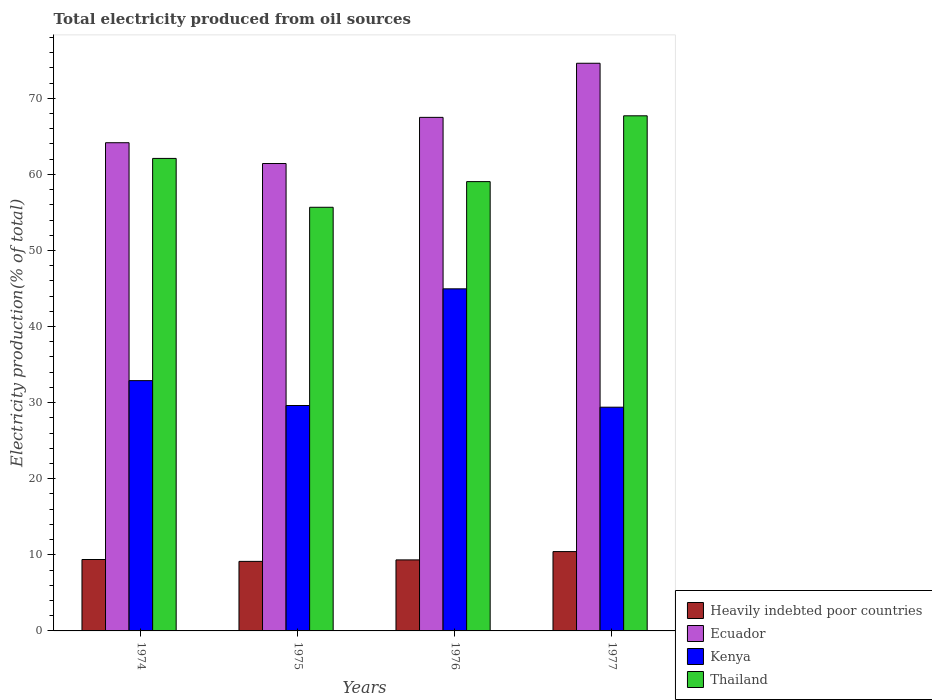How many groups of bars are there?
Ensure brevity in your answer.  4. Are the number of bars per tick equal to the number of legend labels?
Keep it short and to the point. Yes. How many bars are there on the 3rd tick from the left?
Give a very brief answer. 4. How many bars are there on the 2nd tick from the right?
Keep it short and to the point. 4. What is the label of the 1st group of bars from the left?
Your answer should be compact. 1974. What is the total electricity produced in Ecuador in 1974?
Offer a terse response. 64.16. Across all years, what is the maximum total electricity produced in Heavily indebted poor countries?
Make the answer very short. 10.43. Across all years, what is the minimum total electricity produced in Thailand?
Give a very brief answer. 55.68. In which year was the total electricity produced in Thailand maximum?
Your answer should be very brief. 1977. In which year was the total electricity produced in Thailand minimum?
Offer a very short reply. 1975. What is the total total electricity produced in Kenya in the graph?
Your answer should be compact. 136.87. What is the difference between the total electricity produced in Heavily indebted poor countries in 1974 and that in 1975?
Provide a succinct answer. 0.24. What is the difference between the total electricity produced in Thailand in 1977 and the total electricity produced in Heavily indebted poor countries in 1974?
Offer a very short reply. 58.31. What is the average total electricity produced in Kenya per year?
Give a very brief answer. 34.22. In the year 1975, what is the difference between the total electricity produced in Thailand and total electricity produced in Heavily indebted poor countries?
Your answer should be very brief. 46.54. What is the ratio of the total electricity produced in Ecuador in 1974 to that in 1977?
Your response must be concise. 0.86. Is the difference between the total electricity produced in Thailand in 1974 and 1977 greater than the difference between the total electricity produced in Heavily indebted poor countries in 1974 and 1977?
Offer a very short reply. No. What is the difference between the highest and the second highest total electricity produced in Heavily indebted poor countries?
Keep it short and to the point. 1.04. What is the difference between the highest and the lowest total electricity produced in Heavily indebted poor countries?
Offer a terse response. 1.29. Is the sum of the total electricity produced in Thailand in 1974 and 1977 greater than the maximum total electricity produced in Ecuador across all years?
Offer a terse response. Yes. Is it the case that in every year, the sum of the total electricity produced in Thailand and total electricity produced in Kenya is greater than the sum of total electricity produced in Heavily indebted poor countries and total electricity produced in Ecuador?
Provide a short and direct response. Yes. What does the 4th bar from the left in 1975 represents?
Ensure brevity in your answer.  Thailand. What does the 3rd bar from the right in 1974 represents?
Your answer should be very brief. Ecuador. Is it the case that in every year, the sum of the total electricity produced in Kenya and total electricity produced in Heavily indebted poor countries is greater than the total electricity produced in Ecuador?
Your answer should be compact. No. How many bars are there?
Offer a terse response. 16. What is the difference between two consecutive major ticks on the Y-axis?
Provide a succinct answer. 10. Are the values on the major ticks of Y-axis written in scientific E-notation?
Ensure brevity in your answer.  No. Does the graph contain any zero values?
Your answer should be very brief. No. How many legend labels are there?
Ensure brevity in your answer.  4. What is the title of the graph?
Your answer should be very brief. Total electricity produced from oil sources. Does "Bahrain" appear as one of the legend labels in the graph?
Ensure brevity in your answer.  No. What is the label or title of the X-axis?
Offer a very short reply. Years. What is the label or title of the Y-axis?
Provide a succinct answer. Electricity production(% of total). What is the Electricity production(% of total) in Heavily indebted poor countries in 1974?
Offer a terse response. 9.38. What is the Electricity production(% of total) of Ecuador in 1974?
Provide a succinct answer. 64.16. What is the Electricity production(% of total) in Kenya in 1974?
Provide a succinct answer. 32.89. What is the Electricity production(% of total) in Thailand in 1974?
Make the answer very short. 62.1. What is the Electricity production(% of total) of Heavily indebted poor countries in 1975?
Offer a very short reply. 9.14. What is the Electricity production(% of total) in Ecuador in 1975?
Ensure brevity in your answer.  61.43. What is the Electricity production(% of total) of Kenya in 1975?
Offer a terse response. 29.62. What is the Electricity production(% of total) in Thailand in 1975?
Give a very brief answer. 55.68. What is the Electricity production(% of total) in Heavily indebted poor countries in 1976?
Keep it short and to the point. 9.33. What is the Electricity production(% of total) in Ecuador in 1976?
Your response must be concise. 67.49. What is the Electricity production(% of total) in Kenya in 1976?
Offer a terse response. 44.96. What is the Electricity production(% of total) in Thailand in 1976?
Make the answer very short. 59.05. What is the Electricity production(% of total) in Heavily indebted poor countries in 1977?
Your response must be concise. 10.43. What is the Electricity production(% of total) of Ecuador in 1977?
Provide a short and direct response. 74.6. What is the Electricity production(% of total) of Kenya in 1977?
Offer a very short reply. 29.4. What is the Electricity production(% of total) of Thailand in 1977?
Give a very brief answer. 67.7. Across all years, what is the maximum Electricity production(% of total) of Heavily indebted poor countries?
Ensure brevity in your answer.  10.43. Across all years, what is the maximum Electricity production(% of total) of Ecuador?
Keep it short and to the point. 74.6. Across all years, what is the maximum Electricity production(% of total) of Kenya?
Ensure brevity in your answer.  44.96. Across all years, what is the maximum Electricity production(% of total) in Thailand?
Provide a short and direct response. 67.7. Across all years, what is the minimum Electricity production(% of total) of Heavily indebted poor countries?
Keep it short and to the point. 9.14. Across all years, what is the minimum Electricity production(% of total) in Ecuador?
Your answer should be compact. 61.43. Across all years, what is the minimum Electricity production(% of total) in Kenya?
Keep it short and to the point. 29.4. Across all years, what is the minimum Electricity production(% of total) in Thailand?
Offer a very short reply. 55.68. What is the total Electricity production(% of total) in Heavily indebted poor countries in the graph?
Offer a terse response. 38.28. What is the total Electricity production(% of total) of Ecuador in the graph?
Provide a short and direct response. 267.68. What is the total Electricity production(% of total) of Kenya in the graph?
Your answer should be compact. 136.87. What is the total Electricity production(% of total) of Thailand in the graph?
Your answer should be very brief. 244.51. What is the difference between the Electricity production(% of total) in Heavily indebted poor countries in 1974 and that in 1975?
Your answer should be compact. 0.24. What is the difference between the Electricity production(% of total) in Ecuador in 1974 and that in 1975?
Your response must be concise. 2.73. What is the difference between the Electricity production(% of total) of Kenya in 1974 and that in 1975?
Offer a terse response. 3.27. What is the difference between the Electricity production(% of total) of Thailand in 1974 and that in 1975?
Make the answer very short. 6.42. What is the difference between the Electricity production(% of total) in Heavily indebted poor countries in 1974 and that in 1976?
Provide a succinct answer. 0.05. What is the difference between the Electricity production(% of total) in Ecuador in 1974 and that in 1976?
Provide a succinct answer. -3.33. What is the difference between the Electricity production(% of total) of Kenya in 1974 and that in 1976?
Your answer should be very brief. -12.06. What is the difference between the Electricity production(% of total) of Thailand in 1974 and that in 1976?
Give a very brief answer. 3.05. What is the difference between the Electricity production(% of total) in Heavily indebted poor countries in 1974 and that in 1977?
Keep it short and to the point. -1.04. What is the difference between the Electricity production(% of total) in Ecuador in 1974 and that in 1977?
Your answer should be very brief. -10.44. What is the difference between the Electricity production(% of total) in Kenya in 1974 and that in 1977?
Give a very brief answer. 3.49. What is the difference between the Electricity production(% of total) of Thailand in 1974 and that in 1977?
Ensure brevity in your answer.  -5.6. What is the difference between the Electricity production(% of total) in Heavily indebted poor countries in 1975 and that in 1976?
Your answer should be very brief. -0.2. What is the difference between the Electricity production(% of total) of Ecuador in 1975 and that in 1976?
Ensure brevity in your answer.  -6.07. What is the difference between the Electricity production(% of total) of Kenya in 1975 and that in 1976?
Give a very brief answer. -15.33. What is the difference between the Electricity production(% of total) of Thailand in 1975 and that in 1976?
Offer a terse response. -3.37. What is the difference between the Electricity production(% of total) of Heavily indebted poor countries in 1975 and that in 1977?
Provide a succinct answer. -1.29. What is the difference between the Electricity production(% of total) of Ecuador in 1975 and that in 1977?
Your response must be concise. -13.18. What is the difference between the Electricity production(% of total) of Kenya in 1975 and that in 1977?
Provide a succinct answer. 0.22. What is the difference between the Electricity production(% of total) of Thailand in 1975 and that in 1977?
Ensure brevity in your answer.  -12.02. What is the difference between the Electricity production(% of total) of Heavily indebted poor countries in 1976 and that in 1977?
Your response must be concise. -1.09. What is the difference between the Electricity production(% of total) in Ecuador in 1976 and that in 1977?
Your answer should be compact. -7.11. What is the difference between the Electricity production(% of total) in Kenya in 1976 and that in 1977?
Your answer should be compact. 15.55. What is the difference between the Electricity production(% of total) of Thailand in 1976 and that in 1977?
Offer a terse response. -8.65. What is the difference between the Electricity production(% of total) of Heavily indebted poor countries in 1974 and the Electricity production(% of total) of Ecuador in 1975?
Make the answer very short. -52.04. What is the difference between the Electricity production(% of total) of Heavily indebted poor countries in 1974 and the Electricity production(% of total) of Kenya in 1975?
Offer a terse response. -20.24. What is the difference between the Electricity production(% of total) in Heavily indebted poor countries in 1974 and the Electricity production(% of total) in Thailand in 1975?
Offer a very short reply. -46.29. What is the difference between the Electricity production(% of total) in Ecuador in 1974 and the Electricity production(% of total) in Kenya in 1975?
Offer a very short reply. 34.53. What is the difference between the Electricity production(% of total) in Ecuador in 1974 and the Electricity production(% of total) in Thailand in 1975?
Provide a short and direct response. 8.48. What is the difference between the Electricity production(% of total) of Kenya in 1974 and the Electricity production(% of total) of Thailand in 1975?
Your answer should be compact. -22.78. What is the difference between the Electricity production(% of total) of Heavily indebted poor countries in 1974 and the Electricity production(% of total) of Ecuador in 1976?
Give a very brief answer. -58.11. What is the difference between the Electricity production(% of total) of Heavily indebted poor countries in 1974 and the Electricity production(% of total) of Kenya in 1976?
Provide a short and direct response. -35.57. What is the difference between the Electricity production(% of total) of Heavily indebted poor countries in 1974 and the Electricity production(% of total) of Thailand in 1976?
Provide a succinct answer. -49.66. What is the difference between the Electricity production(% of total) in Ecuador in 1974 and the Electricity production(% of total) in Kenya in 1976?
Keep it short and to the point. 19.2. What is the difference between the Electricity production(% of total) in Ecuador in 1974 and the Electricity production(% of total) in Thailand in 1976?
Offer a terse response. 5.11. What is the difference between the Electricity production(% of total) of Kenya in 1974 and the Electricity production(% of total) of Thailand in 1976?
Ensure brevity in your answer.  -26.16. What is the difference between the Electricity production(% of total) in Heavily indebted poor countries in 1974 and the Electricity production(% of total) in Ecuador in 1977?
Ensure brevity in your answer.  -65.22. What is the difference between the Electricity production(% of total) in Heavily indebted poor countries in 1974 and the Electricity production(% of total) in Kenya in 1977?
Give a very brief answer. -20.02. What is the difference between the Electricity production(% of total) of Heavily indebted poor countries in 1974 and the Electricity production(% of total) of Thailand in 1977?
Your answer should be very brief. -58.31. What is the difference between the Electricity production(% of total) of Ecuador in 1974 and the Electricity production(% of total) of Kenya in 1977?
Give a very brief answer. 34.76. What is the difference between the Electricity production(% of total) of Ecuador in 1974 and the Electricity production(% of total) of Thailand in 1977?
Provide a succinct answer. -3.54. What is the difference between the Electricity production(% of total) in Kenya in 1974 and the Electricity production(% of total) in Thailand in 1977?
Make the answer very short. -34.8. What is the difference between the Electricity production(% of total) of Heavily indebted poor countries in 1975 and the Electricity production(% of total) of Ecuador in 1976?
Make the answer very short. -58.35. What is the difference between the Electricity production(% of total) in Heavily indebted poor countries in 1975 and the Electricity production(% of total) in Kenya in 1976?
Your answer should be very brief. -35.82. What is the difference between the Electricity production(% of total) of Heavily indebted poor countries in 1975 and the Electricity production(% of total) of Thailand in 1976?
Offer a terse response. -49.91. What is the difference between the Electricity production(% of total) of Ecuador in 1975 and the Electricity production(% of total) of Kenya in 1976?
Make the answer very short. 16.47. What is the difference between the Electricity production(% of total) of Ecuador in 1975 and the Electricity production(% of total) of Thailand in 1976?
Give a very brief answer. 2.38. What is the difference between the Electricity production(% of total) of Kenya in 1975 and the Electricity production(% of total) of Thailand in 1976?
Give a very brief answer. -29.42. What is the difference between the Electricity production(% of total) of Heavily indebted poor countries in 1975 and the Electricity production(% of total) of Ecuador in 1977?
Give a very brief answer. -65.46. What is the difference between the Electricity production(% of total) in Heavily indebted poor countries in 1975 and the Electricity production(% of total) in Kenya in 1977?
Your answer should be very brief. -20.26. What is the difference between the Electricity production(% of total) in Heavily indebted poor countries in 1975 and the Electricity production(% of total) in Thailand in 1977?
Offer a very short reply. -58.56. What is the difference between the Electricity production(% of total) in Ecuador in 1975 and the Electricity production(% of total) in Kenya in 1977?
Give a very brief answer. 32.02. What is the difference between the Electricity production(% of total) in Ecuador in 1975 and the Electricity production(% of total) in Thailand in 1977?
Your response must be concise. -6.27. What is the difference between the Electricity production(% of total) in Kenya in 1975 and the Electricity production(% of total) in Thailand in 1977?
Offer a terse response. -38.07. What is the difference between the Electricity production(% of total) in Heavily indebted poor countries in 1976 and the Electricity production(% of total) in Ecuador in 1977?
Ensure brevity in your answer.  -65.27. What is the difference between the Electricity production(% of total) in Heavily indebted poor countries in 1976 and the Electricity production(% of total) in Kenya in 1977?
Give a very brief answer. -20.07. What is the difference between the Electricity production(% of total) of Heavily indebted poor countries in 1976 and the Electricity production(% of total) of Thailand in 1977?
Keep it short and to the point. -58.36. What is the difference between the Electricity production(% of total) in Ecuador in 1976 and the Electricity production(% of total) in Kenya in 1977?
Offer a very short reply. 38.09. What is the difference between the Electricity production(% of total) in Ecuador in 1976 and the Electricity production(% of total) in Thailand in 1977?
Provide a short and direct response. -0.21. What is the difference between the Electricity production(% of total) of Kenya in 1976 and the Electricity production(% of total) of Thailand in 1977?
Your response must be concise. -22.74. What is the average Electricity production(% of total) of Heavily indebted poor countries per year?
Offer a terse response. 9.57. What is the average Electricity production(% of total) of Ecuador per year?
Offer a terse response. 66.92. What is the average Electricity production(% of total) in Kenya per year?
Provide a short and direct response. 34.22. What is the average Electricity production(% of total) in Thailand per year?
Provide a succinct answer. 61.13. In the year 1974, what is the difference between the Electricity production(% of total) of Heavily indebted poor countries and Electricity production(% of total) of Ecuador?
Keep it short and to the point. -54.77. In the year 1974, what is the difference between the Electricity production(% of total) in Heavily indebted poor countries and Electricity production(% of total) in Kenya?
Make the answer very short. -23.51. In the year 1974, what is the difference between the Electricity production(% of total) in Heavily indebted poor countries and Electricity production(% of total) in Thailand?
Your response must be concise. -52.71. In the year 1974, what is the difference between the Electricity production(% of total) in Ecuador and Electricity production(% of total) in Kenya?
Give a very brief answer. 31.27. In the year 1974, what is the difference between the Electricity production(% of total) of Ecuador and Electricity production(% of total) of Thailand?
Provide a short and direct response. 2.06. In the year 1974, what is the difference between the Electricity production(% of total) of Kenya and Electricity production(% of total) of Thailand?
Give a very brief answer. -29.2. In the year 1975, what is the difference between the Electricity production(% of total) of Heavily indebted poor countries and Electricity production(% of total) of Ecuador?
Offer a terse response. -52.29. In the year 1975, what is the difference between the Electricity production(% of total) of Heavily indebted poor countries and Electricity production(% of total) of Kenya?
Make the answer very short. -20.48. In the year 1975, what is the difference between the Electricity production(% of total) of Heavily indebted poor countries and Electricity production(% of total) of Thailand?
Offer a terse response. -46.54. In the year 1975, what is the difference between the Electricity production(% of total) in Ecuador and Electricity production(% of total) in Kenya?
Keep it short and to the point. 31.8. In the year 1975, what is the difference between the Electricity production(% of total) of Ecuador and Electricity production(% of total) of Thailand?
Offer a terse response. 5.75. In the year 1975, what is the difference between the Electricity production(% of total) of Kenya and Electricity production(% of total) of Thailand?
Offer a very short reply. -26.05. In the year 1976, what is the difference between the Electricity production(% of total) of Heavily indebted poor countries and Electricity production(% of total) of Ecuador?
Ensure brevity in your answer.  -58.16. In the year 1976, what is the difference between the Electricity production(% of total) of Heavily indebted poor countries and Electricity production(% of total) of Kenya?
Make the answer very short. -35.62. In the year 1976, what is the difference between the Electricity production(% of total) in Heavily indebted poor countries and Electricity production(% of total) in Thailand?
Ensure brevity in your answer.  -49.71. In the year 1976, what is the difference between the Electricity production(% of total) of Ecuador and Electricity production(% of total) of Kenya?
Give a very brief answer. 22.53. In the year 1976, what is the difference between the Electricity production(% of total) in Ecuador and Electricity production(% of total) in Thailand?
Your response must be concise. 8.44. In the year 1976, what is the difference between the Electricity production(% of total) of Kenya and Electricity production(% of total) of Thailand?
Give a very brief answer. -14.09. In the year 1977, what is the difference between the Electricity production(% of total) in Heavily indebted poor countries and Electricity production(% of total) in Ecuador?
Your response must be concise. -64.18. In the year 1977, what is the difference between the Electricity production(% of total) of Heavily indebted poor countries and Electricity production(% of total) of Kenya?
Your answer should be compact. -18.98. In the year 1977, what is the difference between the Electricity production(% of total) of Heavily indebted poor countries and Electricity production(% of total) of Thailand?
Your response must be concise. -57.27. In the year 1977, what is the difference between the Electricity production(% of total) in Ecuador and Electricity production(% of total) in Kenya?
Your answer should be compact. 45.2. In the year 1977, what is the difference between the Electricity production(% of total) of Ecuador and Electricity production(% of total) of Thailand?
Give a very brief answer. 6.91. In the year 1977, what is the difference between the Electricity production(% of total) in Kenya and Electricity production(% of total) in Thailand?
Make the answer very short. -38.29. What is the ratio of the Electricity production(% of total) of Heavily indebted poor countries in 1974 to that in 1975?
Provide a short and direct response. 1.03. What is the ratio of the Electricity production(% of total) in Ecuador in 1974 to that in 1975?
Make the answer very short. 1.04. What is the ratio of the Electricity production(% of total) in Kenya in 1974 to that in 1975?
Ensure brevity in your answer.  1.11. What is the ratio of the Electricity production(% of total) of Thailand in 1974 to that in 1975?
Offer a very short reply. 1.12. What is the ratio of the Electricity production(% of total) in Heavily indebted poor countries in 1974 to that in 1976?
Make the answer very short. 1.01. What is the ratio of the Electricity production(% of total) in Ecuador in 1974 to that in 1976?
Provide a succinct answer. 0.95. What is the ratio of the Electricity production(% of total) in Kenya in 1974 to that in 1976?
Give a very brief answer. 0.73. What is the ratio of the Electricity production(% of total) in Thailand in 1974 to that in 1976?
Make the answer very short. 1.05. What is the ratio of the Electricity production(% of total) of Heavily indebted poor countries in 1974 to that in 1977?
Your answer should be very brief. 0.9. What is the ratio of the Electricity production(% of total) in Ecuador in 1974 to that in 1977?
Give a very brief answer. 0.86. What is the ratio of the Electricity production(% of total) in Kenya in 1974 to that in 1977?
Your response must be concise. 1.12. What is the ratio of the Electricity production(% of total) in Thailand in 1974 to that in 1977?
Ensure brevity in your answer.  0.92. What is the ratio of the Electricity production(% of total) of Heavily indebted poor countries in 1975 to that in 1976?
Your answer should be very brief. 0.98. What is the ratio of the Electricity production(% of total) in Ecuador in 1975 to that in 1976?
Your response must be concise. 0.91. What is the ratio of the Electricity production(% of total) in Kenya in 1975 to that in 1976?
Provide a succinct answer. 0.66. What is the ratio of the Electricity production(% of total) of Thailand in 1975 to that in 1976?
Your response must be concise. 0.94. What is the ratio of the Electricity production(% of total) in Heavily indebted poor countries in 1975 to that in 1977?
Give a very brief answer. 0.88. What is the ratio of the Electricity production(% of total) in Ecuador in 1975 to that in 1977?
Offer a very short reply. 0.82. What is the ratio of the Electricity production(% of total) of Kenya in 1975 to that in 1977?
Your answer should be compact. 1.01. What is the ratio of the Electricity production(% of total) of Thailand in 1975 to that in 1977?
Offer a very short reply. 0.82. What is the ratio of the Electricity production(% of total) in Heavily indebted poor countries in 1976 to that in 1977?
Offer a very short reply. 0.9. What is the ratio of the Electricity production(% of total) in Ecuador in 1976 to that in 1977?
Offer a very short reply. 0.9. What is the ratio of the Electricity production(% of total) in Kenya in 1976 to that in 1977?
Keep it short and to the point. 1.53. What is the ratio of the Electricity production(% of total) of Thailand in 1976 to that in 1977?
Give a very brief answer. 0.87. What is the difference between the highest and the second highest Electricity production(% of total) of Heavily indebted poor countries?
Give a very brief answer. 1.04. What is the difference between the highest and the second highest Electricity production(% of total) of Ecuador?
Your answer should be very brief. 7.11. What is the difference between the highest and the second highest Electricity production(% of total) of Kenya?
Your answer should be compact. 12.06. What is the difference between the highest and the second highest Electricity production(% of total) of Thailand?
Your answer should be very brief. 5.6. What is the difference between the highest and the lowest Electricity production(% of total) in Heavily indebted poor countries?
Offer a very short reply. 1.29. What is the difference between the highest and the lowest Electricity production(% of total) in Ecuador?
Your response must be concise. 13.18. What is the difference between the highest and the lowest Electricity production(% of total) in Kenya?
Your answer should be very brief. 15.55. What is the difference between the highest and the lowest Electricity production(% of total) of Thailand?
Offer a very short reply. 12.02. 